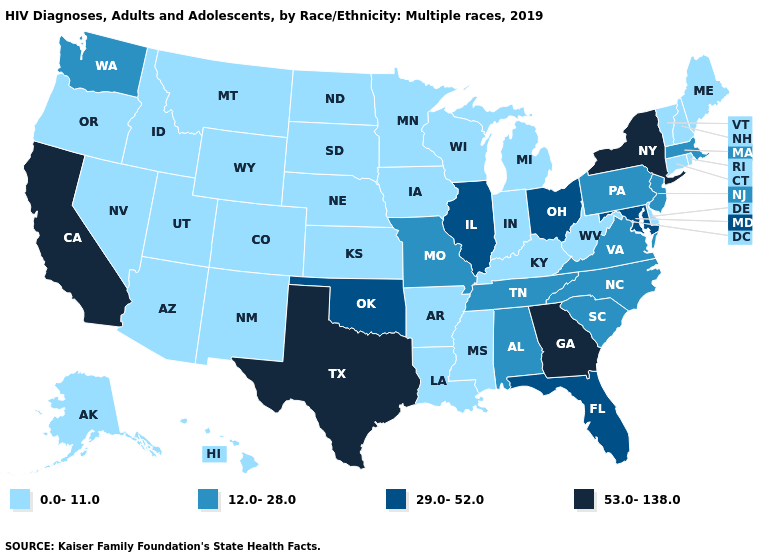What is the lowest value in the USA?
Give a very brief answer. 0.0-11.0. What is the value of Iowa?
Keep it brief. 0.0-11.0. What is the value of Indiana?
Short answer required. 0.0-11.0. Does the map have missing data?
Answer briefly. No. What is the value of New Hampshire?
Write a very short answer. 0.0-11.0. What is the value of Indiana?
Write a very short answer. 0.0-11.0. What is the highest value in states that border Wyoming?
Short answer required. 0.0-11.0. What is the value of Louisiana?
Quick response, please. 0.0-11.0. What is the highest value in the USA?
Give a very brief answer. 53.0-138.0. Among the states that border Oregon , which have the lowest value?
Give a very brief answer. Idaho, Nevada. Does Connecticut have the lowest value in the Northeast?
Be succinct. Yes. Is the legend a continuous bar?
Concise answer only. No. Which states have the lowest value in the USA?
Answer briefly. Alaska, Arizona, Arkansas, Colorado, Connecticut, Delaware, Hawaii, Idaho, Indiana, Iowa, Kansas, Kentucky, Louisiana, Maine, Michigan, Minnesota, Mississippi, Montana, Nebraska, Nevada, New Hampshire, New Mexico, North Dakota, Oregon, Rhode Island, South Dakota, Utah, Vermont, West Virginia, Wisconsin, Wyoming. Does Nebraska have the same value as Oregon?
Be succinct. Yes. Name the states that have a value in the range 12.0-28.0?
Quick response, please. Alabama, Massachusetts, Missouri, New Jersey, North Carolina, Pennsylvania, South Carolina, Tennessee, Virginia, Washington. 